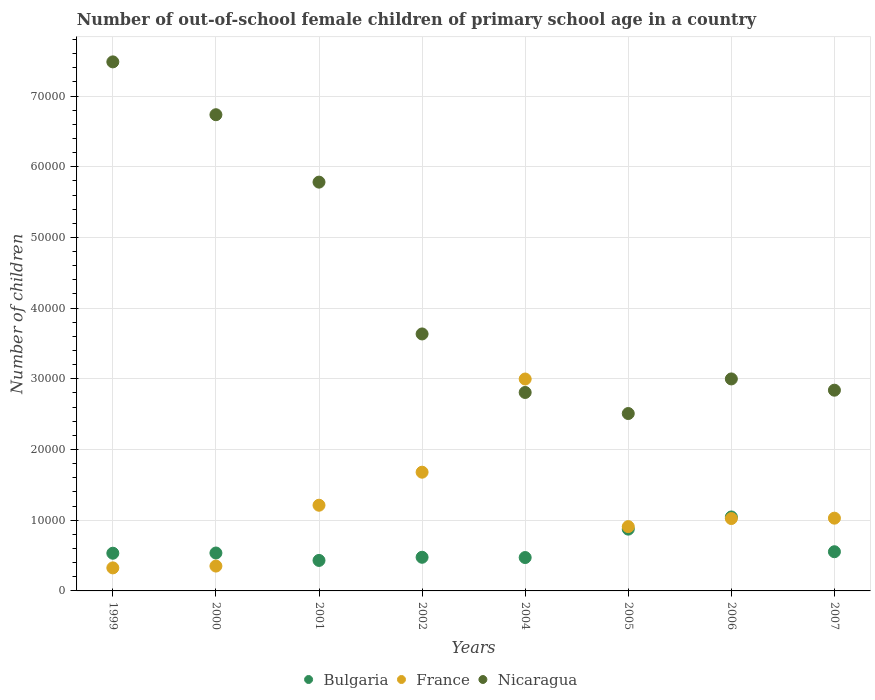What is the number of out-of-school female children in France in 2002?
Make the answer very short. 1.68e+04. Across all years, what is the maximum number of out-of-school female children in Nicaragua?
Offer a terse response. 7.48e+04. Across all years, what is the minimum number of out-of-school female children in France?
Provide a succinct answer. 3258. In which year was the number of out-of-school female children in Nicaragua maximum?
Make the answer very short. 1999. In which year was the number of out-of-school female children in Bulgaria minimum?
Provide a succinct answer. 2001. What is the total number of out-of-school female children in France in the graph?
Give a very brief answer. 9.53e+04. What is the difference between the number of out-of-school female children in Nicaragua in 2001 and that in 2002?
Offer a terse response. 2.15e+04. What is the difference between the number of out-of-school female children in Nicaragua in 2005 and the number of out-of-school female children in Bulgaria in 2007?
Your answer should be very brief. 1.95e+04. What is the average number of out-of-school female children in Bulgaria per year?
Make the answer very short. 6153.88. In the year 2007, what is the difference between the number of out-of-school female children in Nicaragua and number of out-of-school female children in Bulgaria?
Provide a short and direct response. 2.28e+04. What is the ratio of the number of out-of-school female children in Nicaragua in 2001 to that in 2005?
Make the answer very short. 2.3. Is the difference between the number of out-of-school female children in Nicaragua in 2004 and 2007 greater than the difference between the number of out-of-school female children in Bulgaria in 2004 and 2007?
Your response must be concise. Yes. What is the difference between the highest and the second highest number of out-of-school female children in Nicaragua?
Your answer should be very brief. 7474. What is the difference between the highest and the lowest number of out-of-school female children in Bulgaria?
Your response must be concise. 6149. Does the number of out-of-school female children in Nicaragua monotonically increase over the years?
Make the answer very short. No. What is the difference between two consecutive major ticks on the Y-axis?
Give a very brief answer. 10000. Are the values on the major ticks of Y-axis written in scientific E-notation?
Keep it short and to the point. No. Does the graph contain any zero values?
Your response must be concise. No. Where does the legend appear in the graph?
Provide a succinct answer. Bottom center. How many legend labels are there?
Your answer should be very brief. 3. How are the legend labels stacked?
Offer a terse response. Horizontal. What is the title of the graph?
Provide a short and direct response. Number of out-of-school female children of primary school age in a country. What is the label or title of the X-axis?
Your response must be concise. Years. What is the label or title of the Y-axis?
Give a very brief answer. Number of children. What is the Number of children in Bulgaria in 1999?
Your response must be concise. 5332. What is the Number of children in France in 1999?
Offer a terse response. 3258. What is the Number of children in Nicaragua in 1999?
Your response must be concise. 7.48e+04. What is the Number of children in Bulgaria in 2000?
Ensure brevity in your answer.  5362. What is the Number of children in France in 2000?
Offer a terse response. 3514. What is the Number of children in Nicaragua in 2000?
Provide a succinct answer. 6.74e+04. What is the Number of children in Bulgaria in 2001?
Offer a terse response. 4313. What is the Number of children in France in 2001?
Your answer should be very brief. 1.21e+04. What is the Number of children of Nicaragua in 2001?
Give a very brief answer. 5.78e+04. What is the Number of children in Bulgaria in 2002?
Ensure brevity in your answer.  4759. What is the Number of children in France in 2002?
Offer a very short reply. 1.68e+04. What is the Number of children of Nicaragua in 2002?
Your response must be concise. 3.63e+04. What is the Number of children of Bulgaria in 2004?
Keep it short and to the point. 4721. What is the Number of children in France in 2004?
Make the answer very short. 3.00e+04. What is the Number of children of Nicaragua in 2004?
Your answer should be compact. 2.81e+04. What is the Number of children of Bulgaria in 2005?
Provide a short and direct response. 8739. What is the Number of children in France in 2005?
Provide a succinct answer. 9097. What is the Number of children in Nicaragua in 2005?
Ensure brevity in your answer.  2.51e+04. What is the Number of children of Bulgaria in 2006?
Offer a terse response. 1.05e+04. What is the Number of children of France in 2006?
Provide a succinct answer. 1.02e+04. What is the Number of children in Nicaragua in 2006?
Your answer should be very brief. 3.00e+04. What is the Number of children in Bulgaria in 2007?
Give a very brief answer. 5543. What is the Number of children in France in 2007?
Offer a very short reply. 1.03e+04. What is the Number of children in Nicaragua in 2007?
Offer a very short reply. 2.84e+04. Across all years, what is the maximum Number of children in Bulgaria?
Provide a short and direct response. 1.05e+04. Across all years, what is the maximum Number of children of France?
Ensure brevity in your answer.  3.00e+04. Across all years, what is the maximum Number of children of Nicaragua?
Provide a succinct answer. 7.48e+04. Across all years, what is the minimum Number of children in Bulgaria?
Ensure brevity in your answer.  4313. Across all years, what is the minimum Number of children in France?
Ensure brevity in your answer.  3258. Across all years, what is the minimum Number of children of Nicaragua?
Provide a short and direct response. 2.51e+04. What is the total Number of children in Bulgaria in the graph?
Provide a short and direct response. 4.92e+04. What is the total Number of children in France in the graph?
Your answer should be compact. 9.53e+04. What is the total Number of children of Nicaragua in the graph?
Make the answer very short. 3.48e+05. What is the difference between the Number of children of France in 1999 and that in 2000?
Ensure brevity in your answer.  -256. What is the difference between the Number of children in Nicaragua in 1999 and that in 2000?
Your answer should be very brief. 7474. What is the difference between the Number of children in Bulgaria in 1999 and that in 2001?
Your answer should be very brief. 1019. What is the difference between the Number of children in France in 1999 and that in 2001?
Your answer should be compact. -8862. What is the difference between the Number of children of Nicaragua in 1999 and that in 2001?
Provide a short and direct response. 1.70e+04. What is the difference between the Number of children in Bulgaria in 1999 and that in 2002?
Your response must be concise. 573. What is the difference between the Number of children of France in 1999 and that in 2002?
Provide a short and direct response. -1.35e+04. What is the difference between the Number of children of Nicaragua in 1999 and that in 2002?
Your answer should be compact. 3.85e+04. What is the difference between the Number of children in Bulgaria in 1999 and that in 2004?
Provide a succinct answer. 611. What is the difference between the Number of children of France in 1999 and that in 2004?
Provide a short and direct response. -2.67e+04. What is the difference between the Number of children in Nicaragua in 1999 and that in 2004?
Ensure brevity in your answer.  4.68e+04. What is the difference between the Number of children of Bulgaria in 1999 and that in 2005?
Make the answer very short. -3407. What is the difference between the Number of children in France in 1999 and that in 2005?
Ensure brevity in your answer.  -5839. What is the difference between the Number of children in Nicaragua in 1999 and that in 2005?
Your answer should be compact. 4.97e+04. What is the difference between the Number of children in Bulgaria in 1999 and that in 2006?
Keep it short and to the point. -5130. What is the difference between the Number of children in France in 1999 and that in 2006?
Give a very brief answer. -6980. What is the difference between the Number of children in Nicaragua in 1999 and that in 2006?
Keep it short and to the point. 4.48e+04. What is the difference between the Number of children of Bulgaria in 1999 and that in 2007?
Give a very brief answer. -211. What is the difference between the Number of children of France in 1999 and that in 2007?
Give a very brief answer. -7032. What is the difference between the Number of children of Nicaragua in 1999 and that in 2007?
Your response must be concise. 4.64e+04. What is the difference between the Number of children in Bulgaria in 2000 and that in 2001?
Give a very brief answer. 1049. What is the difference between the Number of children of France in 2000 and that in 2001?
Keep it short and to the point. -8606. What is the difference between the Number of children of Nicaragua in 2000 and that in 2001?
Provide a short and direct response. 9535. What is the difference between the Number of children of Bulgaria in 2000 and that in 2002?
Offer a terse response. 603. What is the difference between the Number of children of France in 2000 and that in 2002?
Offer a terse response. -1.33e+04. What is the difference between the Number of children in Nicaragua in 2000 and that in 2002?
Your answer should be compact. 3.10e+04. What is the difference between the Number of children of Bulgaria in 2000 and that in 2004?
Your response must be concise. 641. What is the difference between the Number of children in France in 2000 and that in 2004?
Keep it short and to the point. -2.65e+04. What is the difference between the Number of children in Nicaragua in 2000 and that in 2004?
Offer a very short reply. 3.93e+04. What is the difference between the Number of children of Bulgaria in 2000 and that in 2005?
Give a very brief answer. -3377. What is the difference between the Number of children in France in 2000 and that in 2005?
Provide a short and direct response. -5583. What is the difference between the Number of children of Nicaragua in 2000 and that in 2005?
Your response must be concise. 4.23e+04. What is the difference between the Number of children of Bulgaria in 2000 and that in 2006?
Keep it short and to the point. -5100. What is the difference between the Number of children of France in 2000 and that in 2006?
Ensure brevity in your answer.  -6724. What is the difference between the Number of children in Nicaragua in 2000 and that in 2006?
Your answer should be very brief. 3.74e+04. What is the difference between the Number of children in Bulgaria in 2000 and that in 2007?
Give a very brief answer. -181. What is the difference between the Number of children in France in 2000 and that in 2007?
Offer a terse response. -6776. What is the difference between the Number of children in Nicaragua in 2000 and that in 2007?
Offer a terse response. 3.90e+04. What is the difference between the Number of children of Bulgaria in 2001 and that in 2002?
Your answer should be compact. -446. What is the difference between the Number of children of France in 2001 and that in 2002?
Make the answer very short. -4672. What is the difference between the Number of children of Nicaragua in 2001 and that in 2002?
Your answer should be very brief. 2.15e+04. What is the difference between the Number of children in Bulgaria in 2001 and that in 2004?
Your answer should be very brief. -408. What is the difference between the Number of children of France in 2001 and that in 2004?
Make the answer very short. -1.79e+04. What is the difference between the Number of children of Nicaragua in 2001 and that in 2004?
Make the answer very short. 2.98e+04. What is the difference between the Number of children of Bulgaria in 2001 and that in 2005?
Ensure brevity in your answer.  -4426. What is the difference between the Number of children in France in 2001 and that in 2005?
Provide a succinct answer. 3023. What is the difference between the Number of children of Nicaragua in 2001 and that in 2005?
Your answer should be very brief. 3.27e+04. What is the difference between the Number of children of Bulgaria in 2001 and that in 2006?
Your response must be concise. -6149. What is the difference between the Number of children in France in 2001 and that in 2006?
Give a very brief answer. 1882. What is the difference between the Number of children of Nicaragua in 2001 and that in 2006?
Give a very brief answer. 2.78e+04. What is the difference between the Number of children in Bulgaria in 2001 and that in 2007?
Your response must be concise. -1230. What is the difference between the Number of children of France in 2001 and that in 2007?
Give a very brief answer. 1830. What is the difference between the Number of children in Nicaragua in 2001 and that in 2007?
Make the answer very short. 2.94e+04. What is the difference between the Number of children of France in 2002 and that in 2004?
Keep it short and to the point. -1.32e+04. What is the difference between the Number of children in Nicaragua in 2002 and that in 2004?
Provide a succinct answer. 8278. What is the difference between the Number of children of Bulgaria in 2002 and that in 2005?
Provide a succinct answer. -3980. What is the difference between the Number of children of France in 2002 and that in 2005?
Provide a succinct answer. 7695. What is the difference between the Number of children in Nicaragua in 2002 and that in 2005?
Provide a succinct answer. 1.13e+04. What is the difference between the Number of children in Bulgaria in 2002 and that in 2006?
Your answer should be compact. -5703. What is the difference between the Number of children of France in 2002 and that in 2006?
Your answer should be very brief. 6554. What is the difference between the Number of children in Nicaragua in 2002 and that in 2006?
Your answer should be very brief. 6362. What is the difference between the Number of children of Bulgaria in 2002 and that in 2007?
Ensure brevity in your answer.  -784. What is the difference between the Number of children of France in 2002 and that in 2007?
Offer a terse response. 6502. What is the difference between the Number of children in Nicaragua in 2002 and that in 2007?
Offer a very short reply. 7955. What is the difference between the Number of children in Bulgaria in 2004 and that in 2005?
Provide a short and direct response. -4018. What is the difference between the Number of children of France in 2004 and that in 2005?
Offer a terse response. 2.09e+04. What is the difference between the Number of children in Nicaragua in 2004 and that in 2005?
Provide a short and direct response. 2978. What is the difference between the Number of children in Bulgaria in 2004 and that in 2006?
Keep it short and to the point. -5741. What is the difference between the Number of children of France in 2004 and that in 2006?
Provide a short and direct response. 1.97e+04. What is the difference between the Number of children of Nicaragua in 2004 and that in 2006?
Keep it short and to the point. -1916. What is the difference between the Number of children in Bulgaria in 2004 and that in 2007?
Keep it short and to the point. -822. What is the difference between the Number of children in France in 2004 and that in 2007?
Offer a very short reply. 1.97e+04. What is the difference between the Number of children of Nicaragua in 2004 and that in 2007?
Your answer should be very brief. -323. What is the difference between the Number of children in Bulgaria in 2005 and that in 2006?
Ensure brevity in your answer.  -1723. What is the difference between the Number of children in France in 2005 and that in 2006?
Your answer should be very brief. -1141. What is the difference between the Number of children of Nicaragua in 2005 and that in 2006?
Give a very brief answer. -4894. What is the difference between the Number of children of Bulgaria in 2005 and that in 2007?
Make the answer very short. 3196. What is the difference between the Number of children of France in 2005 and that in 2007?
Offer a very short reply. -1193. What is the difference between the Number of children of Nicaragua in 2005 and that in 2007?
Make the answer very short. -3301. What is the difference between the Number of children in Bulgaria in 2006 and that in 2007?
Keep it short and to the point. 4919. What is the difference between the Number of children in France in 2006 and that in 2007?
Offer a terse response. -52. What is the difference between the Number of children of Nicaragua in 2006 and that in 2007?
Give a very brief answer. 1593. What is the difference between the Number of children of Bulgaria in 1999 and the Number of children of France in 2000?
Make the answer very short. 1818. What is the difference between the Number of children in Bulgaria in 1999 and the Number of children in Nicaragua in 2000?
Keep it short and to the point. -6.20e+04. What is the difference between the Number of children in France in 1999 and the Number of children in Nicaragua in 2000?
Give a very brief answer. -6.41e+04. What is the difference between the Number of children of Bulgaria in 1999 and the Number of children of France in 2001?
Ensure brevity in your answer.  -6788. What is the difference between the Number of children in Bulgaria in 1999 and the Number of children in Nicaragua in 2001?
Provide a short and direct response. -5.25e+04. What is the difference between the Number of children of France in 1999 and the Number of children of Nicaragua in 2001?
Offer a terse response. -5.46e+04. What is the difference between the Number of children of Bulgaria in 1999 and the Number of children of France in 2002?
Ensure brevity in your answer.  -1.15e+04. What is the difference between the Number of children in Bulgaria in 1999 and the Number of children in Nicaragua in 2002?
Your answer should be very brief. -3.10e+04. What is the difference between the Number of children in France in 1999 and the Number of children in Nicaragua in 2002?
Provide a short and direct response. -3.31e+04. What is the difference between the Number of children in Bulgaria in 1999 and the Number of children in France in 2004?
Your answer should be compact. -2.46e+04. What is the difference between the Number of children of Bulgaria in 1999 and the Number of children of Nicaragua in 2004?
Provide a succinct answer. -2.27e+04. What is the difference between the Number of children in France in 1999 and the Number of children in Nicaragua in 2004?
Offer a terse response. -2.48e+04. What is the difference between the Number of children in Bulgaria in 1999 and the Number of children in France in 2005?
Provide a succinct answer. -3765. What is the difference between the Number of children in Bulgaria in 1999 and the Number of children in Nicaragua in 2005?
Give a very brief answer. -1.98e+04. What is the difference between the Number of children of France in 1999 and the Number of children of Nicaragua in 2005?
Your answer should be very brief. -2.18e+04. What is the difference between the Number of children of Bulgaria in 1999 and the Number of children of France in 2006?
Provide a succinct answer. -4906. What is the difference between the Number of children in Bulgaria in 1999 and the Number of children in Nicaragua in 2006?
Your response must be concise. -2.47e+04. What is the difference between the Number of children of France in 1999 and the Number of children of Nicaragua in 2006?
Your response must be concise. -2.67e+04. What is the difference between the Number of children in Bulgaria in 1999 and the Number of children in France in 2007?
Provide a succinct answer. -4958. What is the difference between the Number of children of Bulgaria in 1999 and the Number of children of Nicaragua in 2007?
Make the answer very short. -2.31e+04. What is the difference between the Number of children in France in 1999 and the Number of children in Nicaragua in 2007?
Keep it short and to the point. -2.51e+04. What is the difference between the Number of children of Bulgaria in 2000 and the Number of children of France in 2001?
Your answer should be compact. -6758. What is the difference between the Number of children in Bulgaria in 2000 and the Number of children in Nicaragua in 2001?
Give a very brief answer. -5.25e+04. What is the difference between the Number of children of France in 2000 and the Number of children of Nicaragua in 2001?
Provide a short and direct response. -5.43e+04. What is the difference between the Number of children in Bulgaria in 2000 and the Number of children in France in 2002?
Provide a short and direct response. -1.14e+04. What is the difference between the Number of children of Bulgaria in 2000 and the Number of children of Nicaragua in 2002?
Your answer should be very brief. -3.10e+04. What is the difference between the Number of children of France in 2000 and the Number of children of Nicaragua in 2002?
Offer a very short reply. -3.28e+04. What is the difference between the Number of children in Bulgaria in 2000 and the Number of children in France in 2004?
Provide a short and direct response. -2.46e+04. What is the difference between the Number of children of Bulgaria in 2000 and the Number of children of Nicaragua in 2004?
Offer a terse response. -2.27e+04. What is the difference between the Number of children of France in 2000 and the Number of children of Nicaragua in 2004?
Offer a terse response. -2.46e+04. What is the difference between the Number of children in Bulgaria in 2000 and the Number of children in France in 2005?
Ensure brevity in your answer.  -3735. What is the difference between the Number of children of Bulgaria in 2000 and the Number of children of Nicaragua in 2005?
Provide a short and direct response. -1.97e+04. What is the difference between the Number of children of France in 2000 and the Number of children of Nicaragua in 2005?
Provide a succinct answer. -2.16e+04. What is the difference between the Number of children of Bulgaria in 2000 and the Number of children of France in 2006?
Provide a succinct answer. -4876. What is the difference between the Number of children in Bulgaria in 2000 and the Number of children in Nicaragua in 2006?
Your response must be concise. -2.46e+04. What is the difference between the Number of children in France in 2000 and the Number of children in Nicaragua in 2006?
Your answer should be compact. -2.65e+04. What is the difference between the Number of children of Bulgaria in 2000 and the Number of children of France in 2007?
Offer a terse response. -4928. What is the difference between the Number of children in Bulgaria in 2000 and the Number of children in Nicaragua in 2007?
Your response must be concise. -2.30e+04. What is the difference between the Number of children of France in 2000 and the Number of children of Nicaragua in 2007?
Your response must be concise. -2.49e+04. What is the difference between the Number of children of Bulgaria in 2001 and the Number of children of France in 2002?
Make the answer very short. -1.25e+04. What is the difference between the Number of children in Bulgaria in 2001 and the Number of children in Nicaragua in 2002?
Your answer should be very brief. -3.20e+04. What is the difference between the Number of children in France in 2001 and the Number of children in Nicaragua in 2002?
Provide a succinct answer. -2.42e+04. What is the difference between the Number of children in Bulgaria in 2001 and the Number of children in France in 2004?
Give a very brief answer. -2.57e+04. What is the difference between the Number of children in Bulgaria in 2001 and the Number of children in Nicaragua in 2004?
Keep it short and to the point. -2.38e+04. What is the difference between the Number of children in France in 2001 and the Number of children in Nicaragua in 2004?
Ensure brevity in your answer.  -1.59e+04. What is the difference between the Number of children of Bulgaria in 2001 and the Number of children of France in 2005?
Your response must be concise. -4784. What is the difference between the Number of children of Bulgaria in 2001 and the Number of children of Nicaragua in 2005?
Give a very brief answer. -2.08e+04. What is the difference between the Number of children in France in 2001 and the Number of children in Nicaragua in 2005?
Offer a very short reply. -1.30e+04. What is the difference between the Number of children in Bulgaria in 2001 and the Number of children in France in 2006?
Give a very brief answer. -5925. What is the difference between the Number of children of Bulgaria in 2001 and the Number of children of Nicaragua in 2006?
Provide a succinct answer. -2.57e+04. What is the difference between the Number of children of France in 2001 and the Number of children of Nicaragua in 2006?
Give a very brief answer. -1.79e+04. What is the difference between the Number of children of Bulgaria in 2001 and the Number of children of France in 2007?
Keep it short and to the point. -5977. What is the difference between the Number of children of Bulgaria in 2001 and the Number of children of Nicaragua in 2007?
Give a very brief answer. -2.41e+04. What is the difference between the Number of children of France in 2001 and the Number of children of Nicaragua in 2007?
Keep it short and to the point. -1.63e+04. What is the difference between the Number of children in Bulgaria in 2002 and the Number of children in France in 2004?
Your response must be concise. -2.52e+04. What is the difference between the Number of children in Bulgaria in 2002 and the Number of children in Nicaragua in 2004?
Offer a very short reply. -2.33e+04. What is the difference between the Number of children of France in 2002 and the Number of children of Nicaragua in 2004?
Offer a very short reply. -1.13e+04. What is the difference between the Number of children of Bulgaria in 2002 and the Number of children of France in 2005?
Provide a short and direct response. -4338. What is the difference between the Number of children in Bulgaria in 2002 and the Number of children in Nicaragua in 2005?
Provide a succinct answer. -2.03e+04. What is the difference between the Number of children of France in 2002 and the Number of children of Nicaragua in 2005?
Give a very brief answer. -8299. What is the difference between the Number of children of Bulgaria in 2002 and the Number of children of France in 2006?
Provide a short and direct response. -5479. What is the difference between the Number of children of Bulgaria in 2002 and the Number of children of Nicaragua in 2006?
Your response must be concise. -2.52e+04. What is the difference between the Number of children in France in 2002 and the Number of children in Nicaragua in 2006?
Your answer should be very brief. -1.32e+04. What is the difference between the Number of children of Bulgaria in 2002 and the Number of children of France in 2007?
Make the answer very short. -5531. What is the difference between the Number of children in Bulgaria in 2002 and the Number of children in Nicaragua in 2007?
Your answer should be very brief. -2.36e+04. What is the difference between the Number of children of France in 2002 and the Number of children of Nicaragua in 2007?
Ensure brevity in your answer.  -1.16e+04. What is the difference between the Number of children in Bulgaria in 2004 and the Number of children in France in 2005?
Offer a very short reply. -4376. What is the difference between the Number of children of Bulgaria in 2004 and the Number of children of Nicaragua in 2005?
Give a very brief answer. -2.04e+04. What is the difference between the Number of children of France in 2004 and the Number of children of Nicaragua in 2005?
Provide a succinct answer. 4882. What is the difference between the Number of children of Bulgaria in 2004 and the Number of children of France in 2006?
Make the answer very short. -5517. What is the difference between the Number of children in Bulgaria in 2004 and the Number of children in Nicaragua in 2006?
Provide a succinct answer. -2.53e+04. What is the difference between the Number of children in France in 2004 and the Number of children in Nicaragua in 2006?
Ensure brevity in your answer.  -12. What is the difference between the Number of children of Bulgaria in 2004 and the Number of children of France in 2007?
Keep it short and to the point. -5569. What is the difference between the Number of children of Bulgaria in 2004 and the Number of children of Nicaragua in 2007?
Make the answer very short. -2.37e+04. What is the difference between the Number of children of France in 2004 and the Number of children of Nicaragua in 2007?
Give a very brief answer. 1581. What is the difference between the Number of children in Bulgaria in 2005 and the Number of children in France in 2006?
Provide a succinct answer. -1499. What is the difference between the Number of children of Bulgaria in 2005 and the Number of children of Nicaragua in 2006?
Provide a short and direct response. -2.12e+04. What is the difference between the Number of children of France in 2005 and the Number of children of Nicaragua in 2006?
Your answer should be compact. -2.09e+04. What is the difference between the Number of children of Bulgaria in 2005 and the Number of children of France in 2007?
Your answer should be very brief. -1551. What is the difference between the Number of children of Bulgaria in 2005 and the Number of children of Nicaragua in 2007?
Provide a short and direct response. -1.97e+04. What is the difference between the Number of children in France in 2005 and the Number of children in Nicaragua in 2007?
Your answer should be compact. -1.93e+04. What is the difference between the Number of children in Bulgaria in 2006 and the Number of children in France in 2007?
Your response must be concise. 172. What is the difference between the Number of children in Bulgaria in 2006 and the Number of children in Nicaragua in 2007?
Your answer should be very brief. -1.79e+04. What is the difference between the Number of children in France in 2006 and the Number of children in Nicaragua in 2007?
Your answer should be very brief. -1.82e+04. What is the average Number of children of Bulgaria per year?
Keep it short and to the point. 6153.88. What is the average Number of children in France per year?
Give a very brief answer. 1.19e+04. What is the average Number of children of Nicaragua per year?
Offer a terse response. 4.35e+04. In the year 1999, what is the difference between the Number of children in Bulgaria and Number of children in France?
Your answer should be compact. 2074. In the year 1999, what is the difference between the Number of children in Bulgaria and Number of children in Nicaragua?
Your answer should be compact. -6.95e+04. In the year 1999, what is the difference between the Number of children in France and Number of children in Nicaragua?
Make the answer very short. -7.16e+04. In the year 2000, what is the difference between the Number of children of Bulgaria and Number of children of France?
Provide a short and direct response. 1848. In the year 2000, what is the difference between the Number of children in Bulgaria and Number of children in Nicaragua?
Offer a very short reply. -6.20e+04. In the year 2000, what is the difference between the Number of children in France and Number of children in Nicaragua?
Offer a very short reply. -6.38e+04. In the year 2001, what is the difference between the Number of children of Bulgaria and Number of children of France?
Offer a terse response. -7807. In the year 2001, what is the difference between the Number of children of Bulgaria and Number of children of Nicaragua?
Ensure brevity in your answer.  -5.35e+04. In the year 2001, what is the difference between the Number of children in France and Number of children in Nicaragua?
Your response must be concise. -4.57e+04. In the year 2002, what is the difference between the Number of children of Bulgaria and Number of children of France?
Your response must be concise. -1.20e+04. In the year 2002, what is the difference between the Number of children in Bulgaria and Number of children in Nicaragua?
Ensure brevity in your answer.  -3.16e+04. In the year 2002, what is the difference between the Number of children of France and Number of children of Nicaragua?
Give a very brief answer. -1.96e+04. In the year 2004, what is the difference between the Number of children of Bulgaria and Number of children of France?
Provide a succinct answer. -2.53e+04. In the year 2004, what is the difference between the Number of children in Bulgaria and Number of children in Nicaragua?
Your response must be concise. -2.33e+04. In the year 2004, what is the difference between the Number of children in France and Number of children in Nicaragua?
Your answer should be compact. 1904. In the year 2005, what is the difference between the Number of children in Bulgaria and Number of children in France?
Your response must be concise. -358. In the year 2005, what is the difference between the Number of children of Bulgaria and Number of children of Nicaragua?
Your answer should be very brief. -1.64e+04. In the year 2005, what is the difference between the Number of children of France and Number of children of Nicaragua?
Ensure brevity in your answer.  -1.60e+04. In the year 2006, what is the difference between the Number of children of Bulgaria and Number of children of France?
Offer a very short reply. 224. In the year 2006, what is the difference between the Number of children in Bulgaria and Number of children in Nicaragua?
Keep it short and to the point. -1.95e+04. In the year 2006, what is the difference between the Number of children of France and Number of children of Nicaragua?
Keep it short and to the point. -1.97e+04. In the year 2007, what is the difference between the Number of children of Bulgaria and Number of children of France?
Give a very brief answer. -4747. In the year 2007, what is the difference between the Number of children in Bulgaria and Number of children in Nicaragua?
Make the answer very short. -2.28e+04. In the year 2007, what is the difference between the Number of children of France and Number of children of Nicaragua?
Offer a terse response. -1.81e+04. What is the ratio of the Number of children in France in 1999 to that in 2000?
Provide a short and direct response. 0.93. What is the ratio of the Number of children of Nicaragua in 1999 to that in 2000?
Ensure brevity in your answer.  1.11. What is the ratio of the Number of children of Bulgaria in 1999 to that in 2001?
Provide a succinct answer. 1.24. What is the ratio of the Number of children in France in 1999 to that in 2001?
Offer a terse response. 0.27. What is the ratio of the Number of children in Nicaragua in 1999 to that in 2001?
Offer a very short reply. 1.29. What is the ratio of the Number of children in Bulgaria in 1999 to that in 2002?
Offer a very short reply. 1.12. What is the ratio of the Number of children of France in 1999 to that in 2002?
Give a very brief answer. 0.19. What is the ratio of the Number of children in Nicaragua in 1999 to that in 2002?
Provide a succinct answer. 2.06. What is the ratio of the Number of children of Bulgaria in 1999 to that in 2004?
Keep it short and to the point. 1.13. What is the ratio of the Number of children of France in 1999 to that in 2004?
Ensure brevity in your answer.  0.11. What is the ratio of the Number of children of Nicaragua in 1999 to that in 2004?
Your response must be concise. 2.67. What is the ratio of the Number of children of Bulgaria in 1999 to that in 2005?
Provide a short and direct response. 0.61. What is the ratio of the Number of children of France in 1999 to that in 2005?
Your answer should be compact. 0.36. What is the ratio of the Number of children of Nicaragua in 1999 to that in 2005?
Give a very brief answer. 2.98. What is the ratio of the Number of children of Bulgaria in 1999 to that in 2006?
Give a very brief answer. 0.51. What is the ratio of the Number of children in France in 1999 to that in 2006?
Your response must be concise. 0.32. What is the ratio of the Number of children in Nicaragua in 1999 to that in 2006?
Keep it short and to the point. 2.5. What is the ratio of the Number of children in Bulgaria in 1999 to that in 2007?
Provide a short and direct response. 0.96. What is the ratio of the Number of children in France in 1999 to that in 2007?
Ensure brevity in your answer.  0.32. What is the ratio of the Number of children of Nicaragua in 1999 to that in 2007?
Keep it short and to the point. 2.64. What is the ratio of the Number of children of Bulgaria in 2000 to that in 2001?
Ensure brevity in your answer.  1.24. What is the ratio of the Number of children of France in 2000 to that in 2001?
Ensure brevity in your answer.  0.29. What is the ratio of the Number of children in Nicaragua in 2000 to that in 2001?
Your answer should be compact. 1.16. What is the ratio of the Number of children in Bulgaria in 2000 to that in 2002?
Your response must be concise. 1.13. What is the ratio of the Number of children of France in 2000 to that in 2002?
Offer a terse response. 0.21. What is the ratio of the Number of children of Nicaragua in 2000 to that in 2002?
Offer a terse response. 1.85. What is the ratio of the Number of children in Bulgaria in 2000 to that in 2004?
Your answer should be compact. 1.14. What is the ratio of the Number of children of France in 2000 to that in 2004?
Give a very brief answer. 0.12. What is the ratio of the Number of children in Nicaragua in 2000 to that in 2004?
Your answer should be very brief. 2.4. What is the ratio of the Number of children of Bulgaria in 2000 to that in 2005?
Ensure brevity in your answer.  0.61. What is the ratio of the Number of children of France in 2000 to that in 2005?
Ensure brevity in your answer.  0.39. What is the ratio of the Number of children in Nicaragua in 2000 to that in 2005?
Offer a very short reply. 2.68. What is the ratio of the Number of children in Bulgaria in 2000 to that in 2006?
Ensure brevity in your answer.  0.51. What is the ratio of the Number of children of France in 2000 to that in 2006?
Your answer should be very brief. 0.34. What is the ratio of the Number of children in Nicaragua in 2000 to that in 2006?
Offer a terse response. 2.25. What is the ratio of the Number of children in Bulgaria in 2000 to that in 2007?
Offer a very short reply. 0.97. What is the ratio of the Number of children of France in 2000 to that in 2007?
Keep it short and to the point. 0.34. What is the ratio of the Number of children of Nicaragua in 2000 to that in 2007?
Provide a short and direct response. 2.37. What is the ratio of the Number of children in Bulgaria in 2001 to that in 2002?
Ensure brevity in your answer.  0.91. What is the ratio of the Number of children of France in 2001 to that in 2002?
Provide a short and direct response. 0.72. What is the ratio of the Number of children of Nicaragua in 2001 to that in 2002?
Your answer should be compact. 1.59. What is the ratio of the Number of children of Bulgaria in 2001 to that in 2004?
Your response must be concise. 0.91. What is the ratio of the Number of children in France in 2001 to that in 2004?
Your answer should be very brief. 0.4. What is the ratio of the Number of children in Nicaragua in 2001 to that in 2004?
Ensure brevity in your answer.  2.06. What is the ratio of the Number of children in Bulgaria in 2001 to that in 2005?
Your answer should be compact. 0.49. What is the ratio of the Number of children of France in 2001 to that in 2005?
Keep it short and to the point. 1.33. What is the ratio of the Number of children in Nicaragua in 2001 to that in 2005?
Your response must be concise. 2.3. What is the ratio of the Number of children in Bulgaria in 2001 to that in 2006?
Make the answer very short. 0.41. What is the ratio of the Number of children of France in 2001 to that in 2006?
Your answer should be compact. 1.18. What is the ratio of the Number of children of Nicaragua in 2001 to that in 2006?
Your response must be concise. 1.93. What is the ratio of the Number of children in Bulgaria in 2001 to that in 2007?
Make the answer very short. 0.78. What is the ratio of the Number of children in France in 2001 to that in 2007?
Make the answer very short. 1.18. What is the ratio of the Number of children of Nicaragua in 2001 to that in 2007?
Make the answer very short. 2.04. What is the ratio of the Number of children of Bulgaria in 2002 to that in 2004?
Give a very brief answer. 1.01. What is the ratio of the Number of children of France in 2002 to that in 2004?
Give a very brief answer. 0.56. What is the ratio of the Number of children in Nicaragua in 2002 to that in 2004?
Keep it short and to the point. 1.29. What is the ratio of the Number of children of Bulgaria in 2002 to that in 2005?
Give a very brief answer. 0.54. What is the ratio of the Number of children of France in 2002 to that in 2005?
Provide a succinct answer. 1.85. What is the ratio of the Number of children in Nicaragua in 2002 to that in 2005?
Give a very brief answer. 1.45. What is the ratio of the Number of children in Bulgaria in 2002 to that in 2006?
Provide a short and direct response. 0.45. What is the ratio of the Number of children in France in 2002 to that in 2006?
Your answer should be very brief. 1.64. What is the ratio of the Number of children of Nicaragua in 2002 to that in 2006?
Ensure brevity in your answer.  1.21. What is the ratio of the Number of children in Bulgaria in 2002 to that in 2007?
Ensure brevity in your answer.  0.86. What is the ratio of the Number of children of France in 2002 to that in 2007?
Your answer should be compact. 1.63. What is the ratio of the Number of children of Nicaragua in 2002 to that in 2007?
Offer a very short reply. 1.28. What is the ratio of the Number of children in Bulgaria in 2004 to that in 2005?
Your response must be concise. 0.54. What is the ratio of the Number of children of France in 2004 to that in 2005?
Your answer should be very brief. 3.29. What is the ratio of the Number of children in Nicaragua in 2004 to that in 2005?
Make the answer very short. 1.12. What is the ratio of the Number of children of Bulgaria in 2004 to that in 2006?
Keep it short and to the point. 0.45. What is the ratio of the Number of children in France in 2004 to that in 2006?
Provide a short and direct response. 2.93. What is the ratio of the Number of children in Nicaragua in 2004 to that in 2006?
Your response must be concise. 0.94. What is the ratio of the Number of children of Bulgaria in 2004 to that in 2007?
Give a very brief answer. 0.85. What is the ratio of the Number of children in France in 2004 to that in 2007?
Your answer should be compact. 2.91. What is the ratio of the Number of children of Nicaragua in 2004 to that in 2007?
Offer a terse response. 0.99. What is the ratio of the Number of children in Bulgaria in 2005 to that in 2006?
Provide a short and direct response. 0.84. What is the ratio of the Number of children of France in 2005 to that in 2006?
Your answer should be very brief. 0.89. What is the ratio of the Number of children in Nicaragua in 2005 to that in 2006?
Ensure brevity in your answer.  0.84. What is the ratio of the Number of children in Bulgaria in 2005 to that in 2007?
Your answer should be compact. 1.58. What is the ratio of the Number of children in France in 2005 to that in 2007?
Keep it short and to the point. 0.88. What is the ratio of the Number of children in Nicaragua in 2005 to that in 2007?
Your answer should be very brief. 0.88. What is the ratio of the Number of children of Bulgaria in 2006 to that in 2007?
Your answer should be very brief. 1.89. What is the ratio of the Number of children in Nicaragua in 2006 to that in 2007?
Your answer should be very brief. 1.06. What is the difference between the highest and the second highest Number of children of Bulgaria?
Keep it short and to the point. 1723. What is the difference between the highest and the second highest Number of children of France?
Offer a very short reply. 1.32e+04. What is the difference between the highest and the second highest Number of children of Nicaragua?
Offer a very short reply. 7474. What is the difference between the highest and the lowest Number of children in Bulgaria?
Offer a terse response. 6149. What is the difference between the highest and the lowest Number of children of France?
Provide a short and direct response. 2.67e+04. What is the difference between the highest and the lowest Number of children in Nicaragua?
Ensure brevity in your answer.  4.97e+04. 